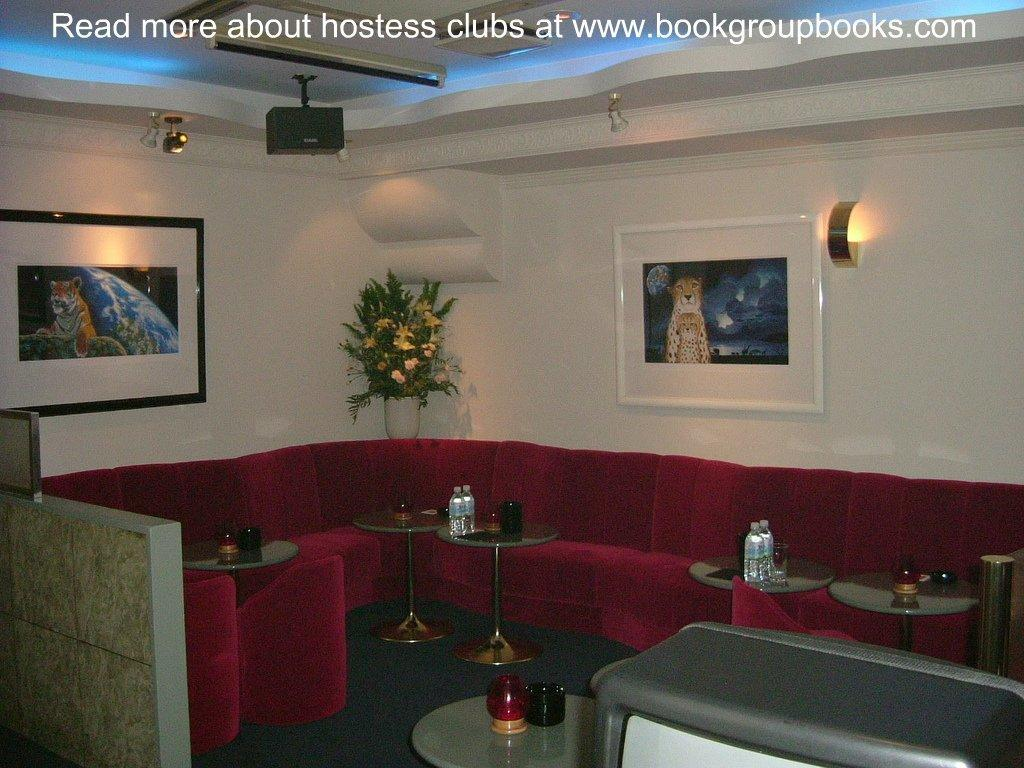What type of furniture is present in the image? There is a couch in the image. What other objects can be seen in the image? There are tables, bottles, cups, and a plant in the image. What can be seen in the background of the image? There is a wall, frames, lights, and a ceiling in the background of the image. What type of mine is visible in the image? There is no mine present in the image. Can you tell me how many whips are being used in the image? There are no whips present in the image. 